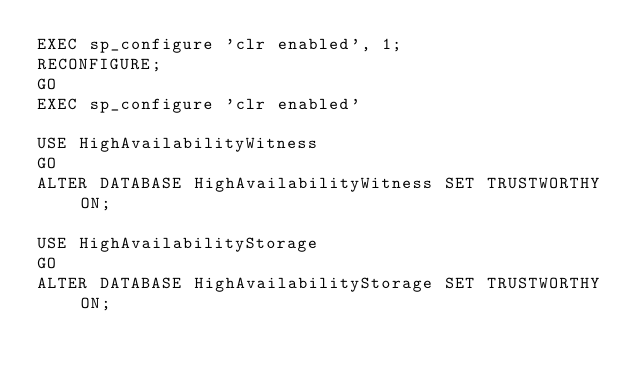Convert code to text. <code><loc_0><loc_0><loc_500><loc_500><_SQL_>EXEC sp_configure 'clr enabled', 1;
RECONFIGURE;
GO
EXEC sp_configure 'clr enabled'

USE HighAvailabilityWitness
GO
ALTER DATABASE HighAvailabilityWitness SET TRUSTWORTHY ON;

USE HighAvailabilityStorage
GO
ALTER DATABASE HighAvailabilityStorage SET TRUSTWORTHY ON;</code> 